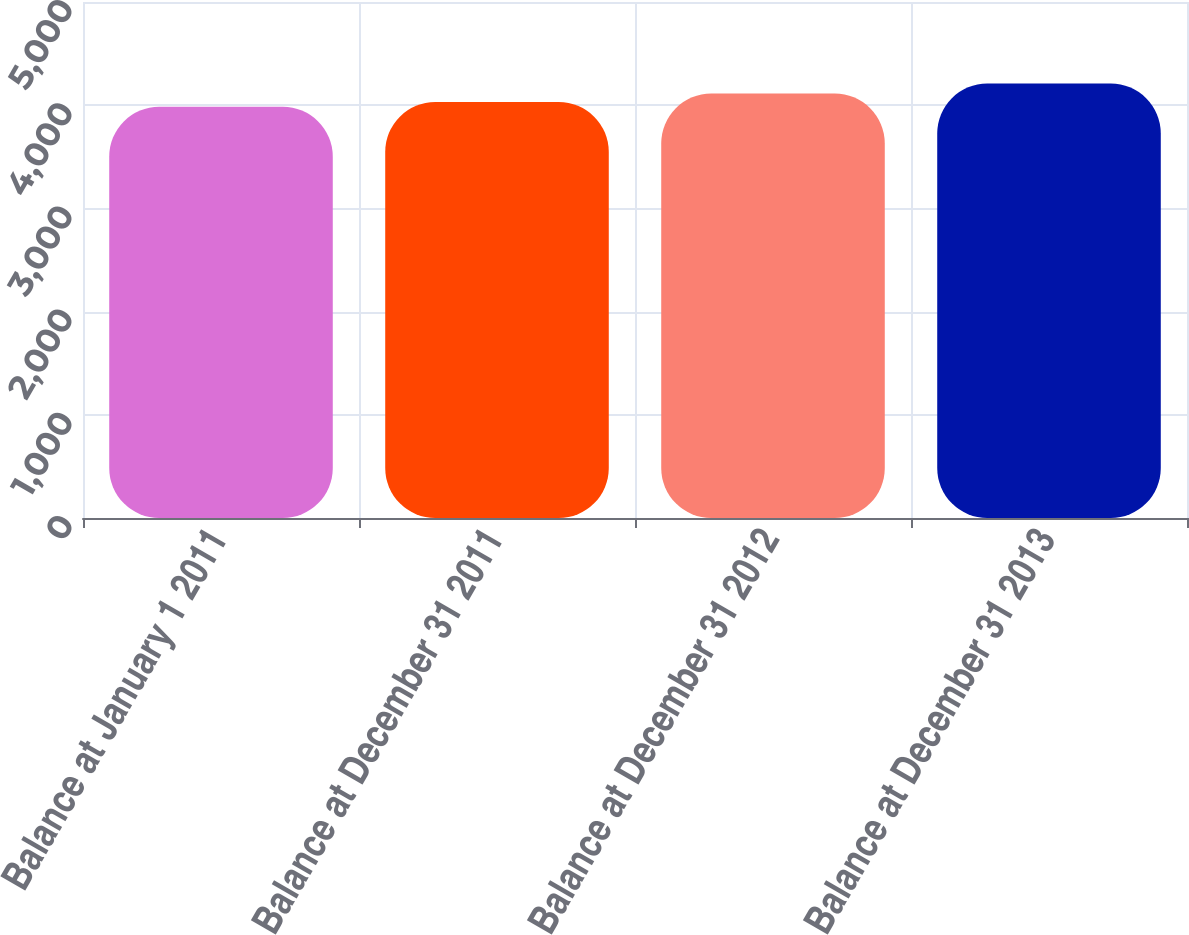Convert chart to OTSL. <chart><loc_0><loc_0><loc_500><loc_500><bar_chart><fcel>Balance at January 1 2011<fcel>Balance at December 31 2011<fcel>Balance at December 31 2012<fcel>Balance at December 31 2013<nl><fcel>3985<fcel>4031<fcel>4113<fcel>4210<nl></chart> 